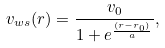Convert formula to latex. <formula><loc_0><loc_0><loc_500><loc_500>v _ { w s } ( r ) = \frac { v _ { 0 } } { 1 + e ^ { \frac { ( r - r _ { 0 } ) } { a } } } ,</formula> 